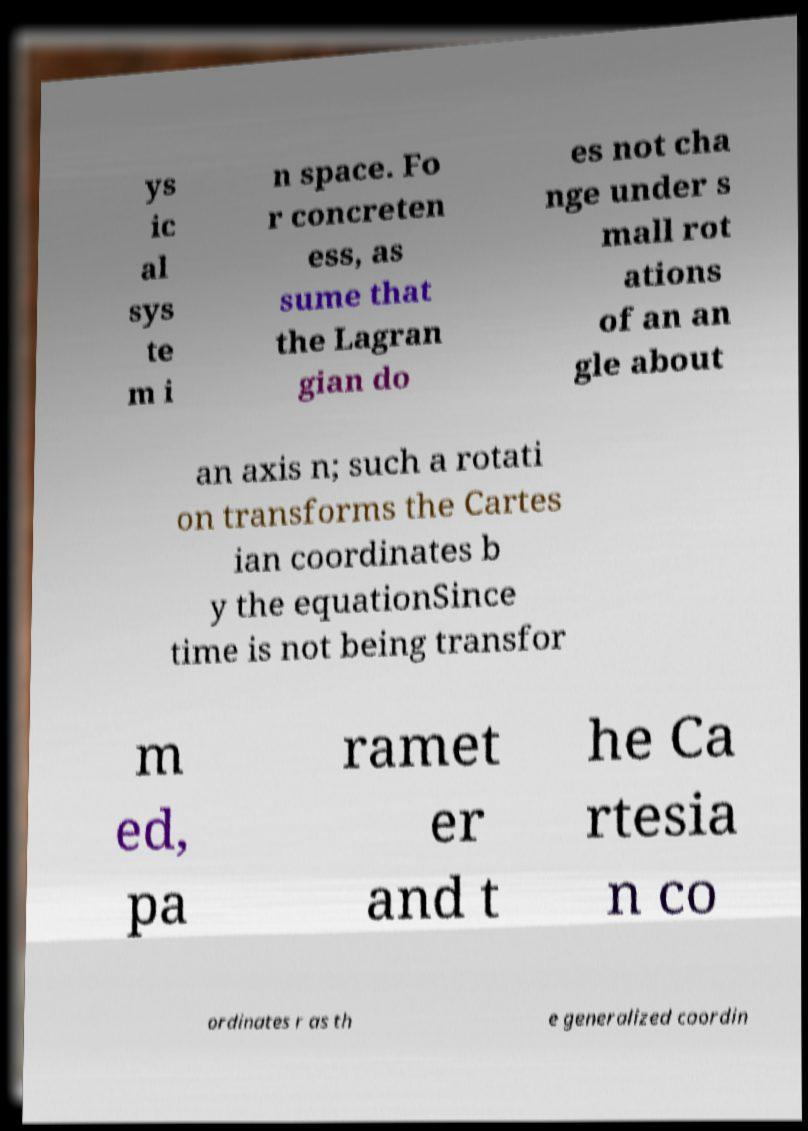For documentation purposes, I need the text within this image transcribed. Could you provide that? ys ic al sys te m i n space. Fo r concreten ess, as sume that the Lagran gian do es not cha nge under s mall rot ations of an an gle about an axis n; such a rotati on transforms the Cartes ian coordinates b y the equationSince time is not being transfor m ed, pa ramet er and t he Ca rtesia n co ordinates r as th e generalized coordin 